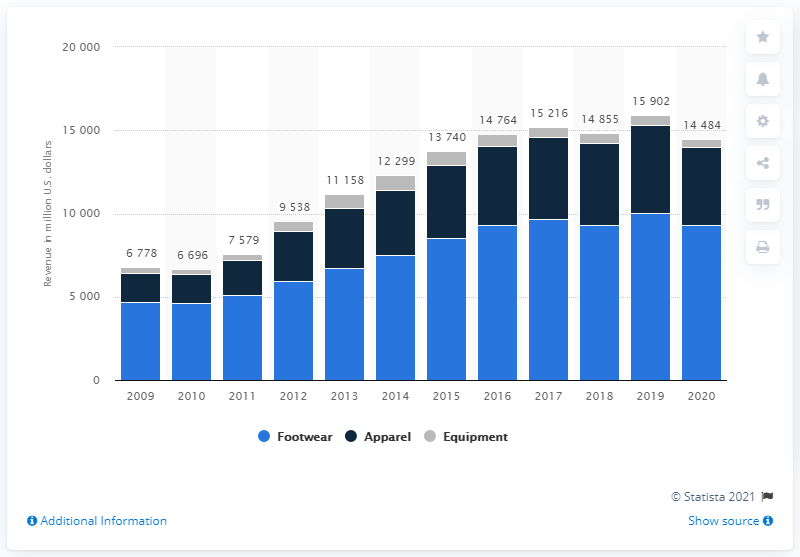Specify some key components in this picture. In 2020, Nike's revenue from footwear in North America was approximately 9,329 million dollars. 